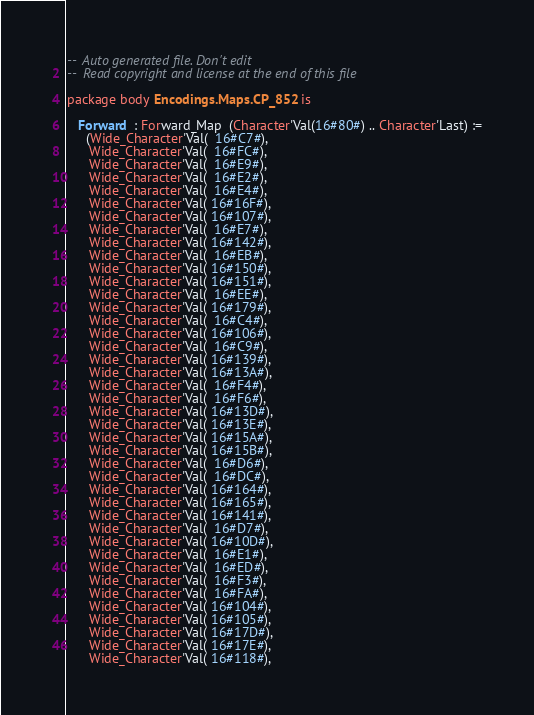<code> <loc_0><loc_0><loc_500><loc_500><_Ada_>--  Auto generated file. Don't edit
--  Read copyright and license at the end of this file

package body Encodings.Maps.CP_852 is

   Forward  : Forward_Map  (Character'Val(16#80#) .. Character'Last) :=
     (Wide_Character'Val(  16#C7#),
      Wide_Character'Val(  16#FC#),
      Wide_Character'Val(  16#E9#),
      Wide_Character'Val(  16#E2#),
      Wide_Character'Val(  16#E4#),
      Wide_Character'Val( 16#16F#),
      Wide_Character'Val( 16#107#),
      Wide_Character'Val(  16#E7#),
      Wide_Character'Val( 16#142#),
      Wide_Character'Val(  16#EB#),
      Wide_Character'Val( 16#150#),
      Wide_Character'Val( 16#151#),
      Wide_Character'Val(  16#EE#),
      Wide_Character'Val( 16#179#),
      Wide_Character'Val(  16#C4#),
      Wide_Character'Val( 16#106#),
      Wide_Character'Val(  16#C9#),
      Wide_Character'Val( 16#139#),
      Wide_Character'Val( 16#13A#),
      Wide_Character'Val(  16#F4#),
      Wide_Character'Val(  16#F6#),
      Wide_Character'Val( 16#13D#),
      Wide_Character'Val( 16#13E#),
      Wide_Character'Val( 16#15A#),
      Wide_Character'Val( 16#15B#),
      Wide_Character'Val(  16#D6#),
      Wide_Character'Val(  16#DC#),
      Wide_Character'Val( 16#164#),
      Wide_Character'Val( 16#165#),
      Wide_Character'Val( 16#141#),
      Wide_Character'Val(  16#D7#),
      Wide_Character'Val( 16#10D#),
      Wide_Character'Val(  16#E1#),
      Wide_Character'Val(  16#ED#),
      Wide_Character'Val(  16#F3#),
      Wide_Character'Val(  16#FA#),
      Wide_Character'Val( 16#104#),
      Wide_Character'Val( 16#105#),
      Wide_Character'Val( 16#17D#),
      Wide_Character'Val( 16#17E#),
      Wide_Character'Val( 16#118#),</code> 